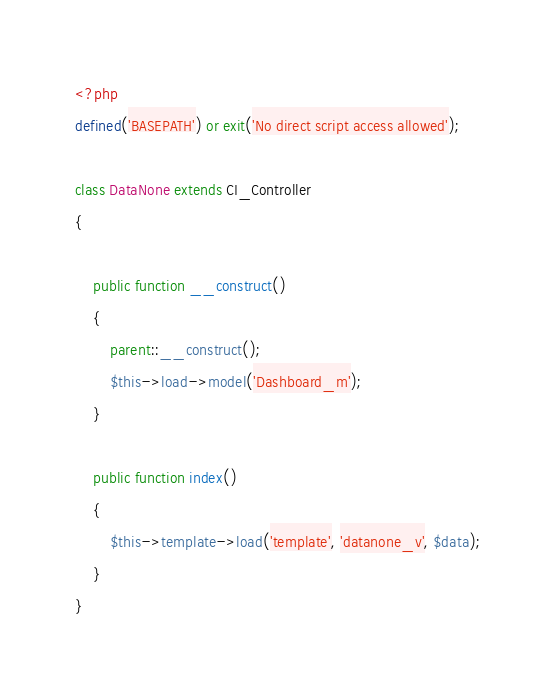Convert code to text. <code><loc_0><loc_0><loc_500><loc_500><_PHP_><?php
defined('BASEPATH') or exit('No direct script access allowed');

class DataNone extends CI_Controller
{

    public function __construct()
    {
        parent::__construct();
        $this->load->model('Dashboard_m');
    }

    public function index()
    {
        $this->template->load('template', 'datanone_v', $data);
    }
}
</code> 